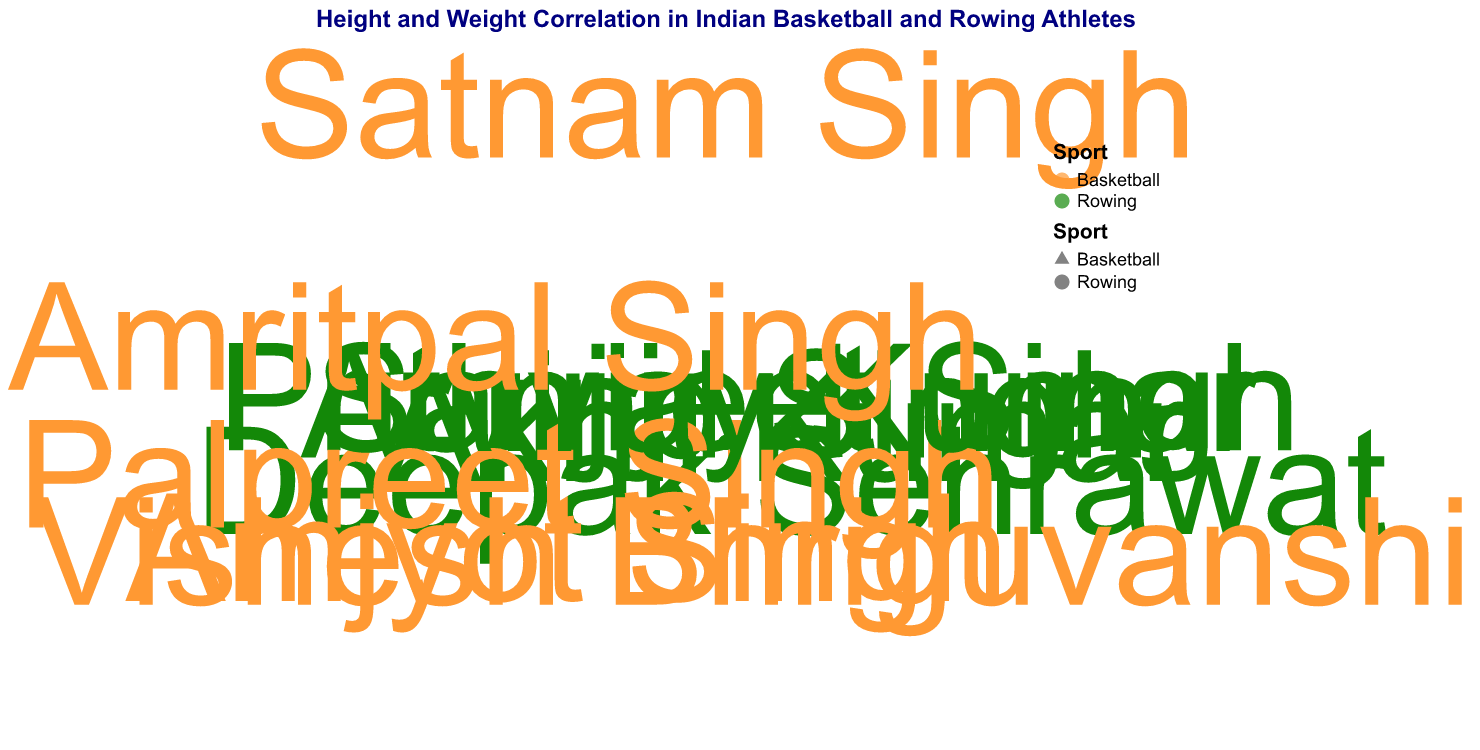How many athletes are represented in the figure? To find the number of athletes, you need to count the data points shown in the figure.
Answer: 10 How many data points belong to rowing athletes? Identify the data points labeled or marked with the color and shape representing rowing and count them.
Answer: 5 Which athlete has the highest weight, and what is their weight? Look for the point furthest from the center on the radial axis; this point represents the athlete with the highest weight.
Answer: Satnam Singh, 132 kg Which sport has athletes with a higher average height? Calculate the average height of all athletes in each sport. For basketball: (218 + 203 + 195 + 206 + 210) / 5 = 206.4 cm. For rowing: (185 + 190 + 180 + 175 + 182) / 5 = 182.4 cm. Compare the two averages.
Answer: Basketball What is the height of the tallest rowing athlete? Locate the point labeled with the highest value on the angular axis for rowing athletes.
Answer: 190 cm Who are the athletes with the same weight of 80 kg, and what are their respective sports? Identify the points with a radius corresponding to 80 kg and read the associated names and sports.
Answer: Sanjay Kumar (Rowing), Akhil Kumar (Rowing) Are there more basketball or rowing athletes with heights above 200 cm? Count the number of points for each sport above the 200 cm mark on the angular axis. For basketball: 5 athletes. For rowing: 0 athletes.
Answer: Basketball Which athlete is closest to the average height of all athletes, and what is their height? First, find the average height: (185 + 218 + 190 + 203 + 180 + 195 + 175 + 206 + 182 + 210) / 10 = 194.4 cm. Identify the athlete whose height is closest to this value.
Answer: Vishesh Bhriguvanshi, 195 cm Is there any overlap in the height range (i.e., the minimum and maximum height) between the two sports? Compare the minimum and maximum heights for each sport. Rowing: min 175 cm, max 190 cm. Basketball: min 195 cm, max 218 cm.
Answer: No What is the average weight of the basketball athletes? Calculate the average weight of all basketball athletes: (132 + 105 + 90 + 110 + 116) / 5 = 110.6 kg.
Answer: 110.6 kg 